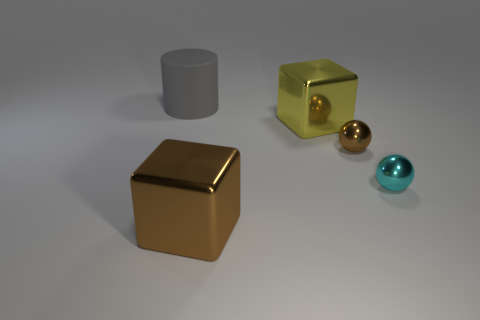What could be the purpose of arranging these objects like this? This type of arrangement could be for a visual composition exercise, studying reflections and shadows, or possibly for a product display or a graphic design element.  Are these objects appearing to be of a particular material? Yes, the large cylinder appears to be made of a matte material, while the gold cube and sphere seem to be metallic. The turquoise sphere looks like glass or a shiny plastic, and the yellow cube has a translucent appearance, possibly glass or acrylic. 